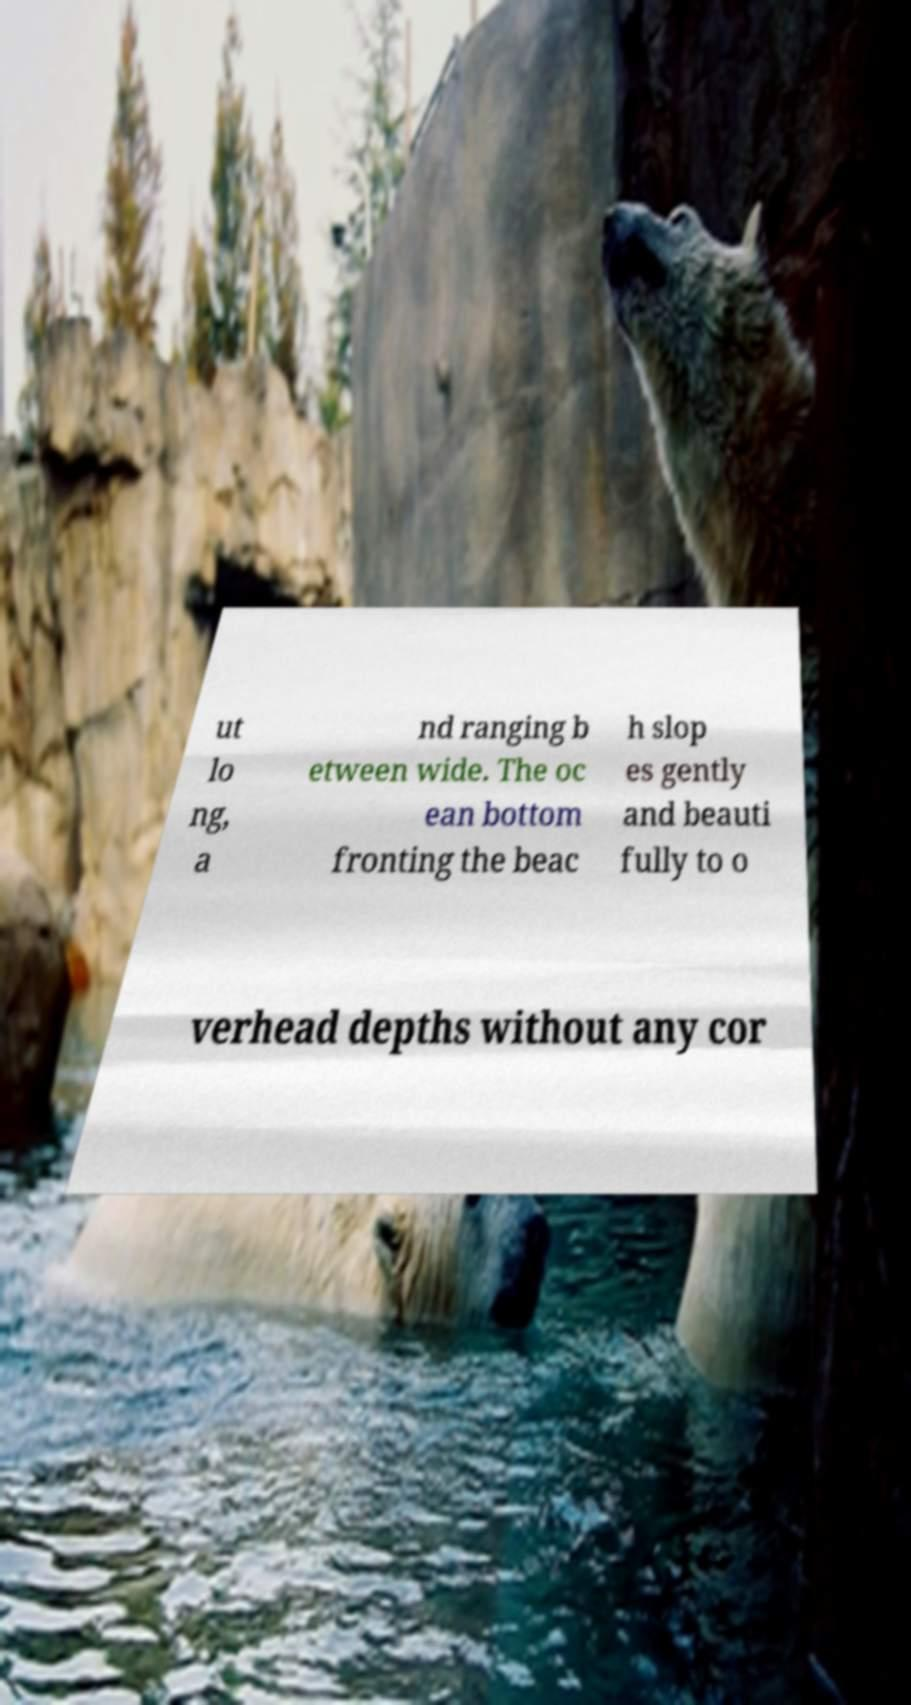Could you assist in decoding the text presented in this image and type it out clearly? ut lo ng, a nd ranging b etween wide. The oc ean bottom fronting the beac h slop es gently and beauti fully to o verhead depths without any cor 